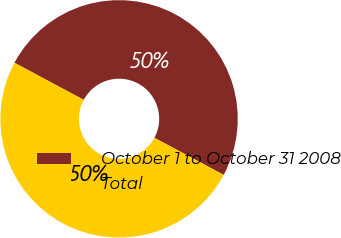<chart> <loc_0><loc_0><loc_500><loc_500><pie_chart><fcel>October 1 to October 31 2008<fcel>Total<nl><fcel>50.0%<fcel>50.0%<nl></chart> 